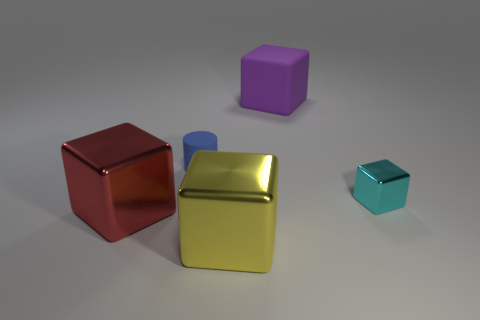Is there any other thing that is the same shape as the small blue rubber thing?
Your response must be concise. No. What number of tiny blue cylinders are in front of the big metal cube that is left of the small rubber thing?
Offer a terse response. 0. There is a rubber thing on the left side of the purple matte block; is it the same size as the cube to the left of the yellow shiny thing?
Your response must be concise. No. How many yellow shiny cubes are there?
Your answer should be very brief. 1. What number of yellow things are the same material as the red block?
Offer a terse response. 1. Are there the same number of big yellow blocks that are right of the cyan object and gray matte cylinders?
Offer a terse response. Yes. There is a cylinder; is it the same size as the red shiny object that is behind the large yellow block?
Give a very brief answer. No. How many other objects are there of the same size as the red block?
Offer a terse response. 2. What number of other objects are the same color as the tiny cube?
Provide a short and direct response. 0. What number of other objects are there of the same shape as the large purple rubber object?
Your answer should be very brief. 3. 